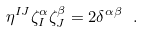Convert formula to latex. <formula><loc_0><loc_0><loc_500><loc_500>\eta ^ { I J } \zeta ^ { \alpha } _ { I } \zeta ^ { \beta } _ { J } = 2 \delta ^ { \alpha \beta } \ .</formula> 